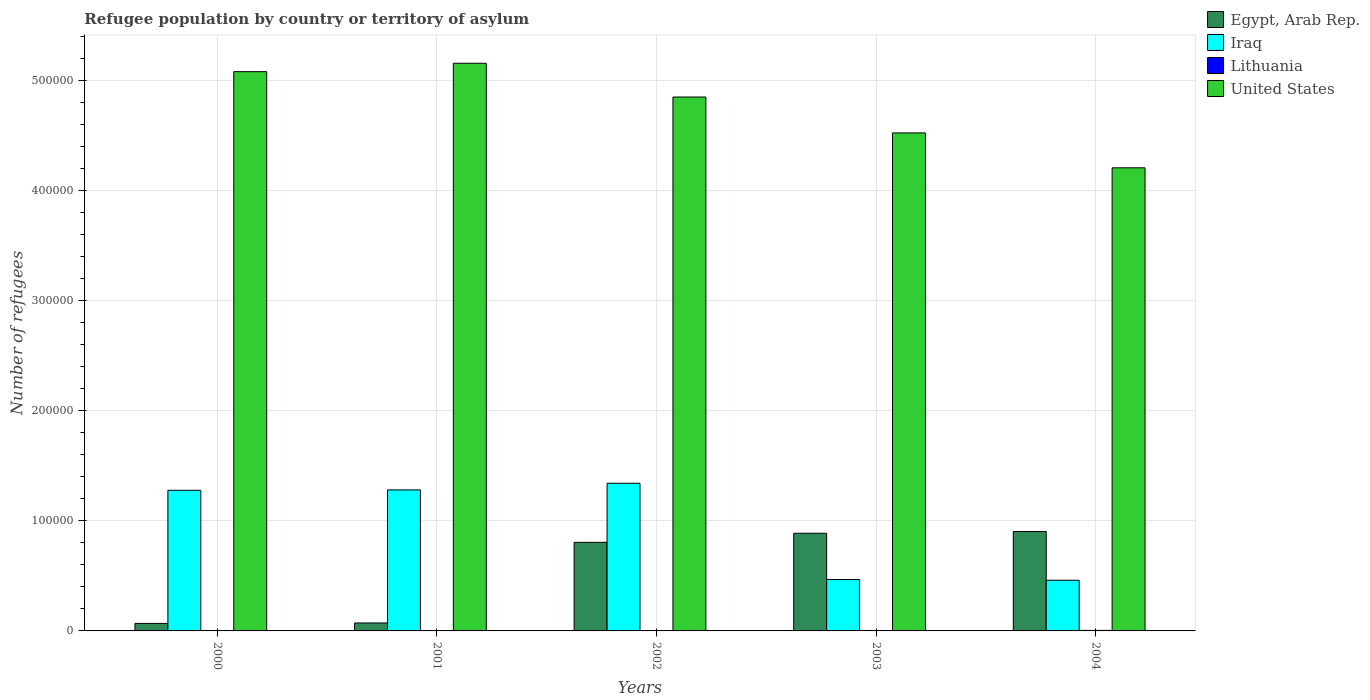How many bars are there on the 5th tick from the left?
Offer a terse response. 4. How many bars are there on the 5th tick from the right?
Make the answer very short. 4. What is the label of the 4th group of bars from the left?
Ensure brevity in your answer.  2003. In how many cases, is the number of bars for a given year not equal to the number of legend labels?
Your answer should be compact. 0. What is the number of refugees in United States in 2000?
Offer a terse response. 5.08e+05. Across all years, what is the maximum number of refugees in Iraq?
Offer a very short reply. 1.34e+05. Across all years, what is the minimum number of refugees in Iraq?
Your answer should be very brief. 4.61e+04. In which year was the number of refugees in United States minimum?
Your answer should be compact. 2004. What is the total number of refugees in United States in the graph?
Ensure brevity in your answer.  2.38e+06. What is the difference between the number of refugees in Iraq in 2002 and that in 2003?
Keep it short and to the point. 8.75e+04. What is the difference between the number of refugees in Egypt, Arab Rep. in 2001 and the number of refugees in United States in 2002?
Offer a terse response. -4.78e+05. What is the average number of refugees in Lithuania per year?
Offer a very short reply. 316.6. In the year 2004, what is the difference between the number of refugees in Lithuania and number of refugees in Iraq?
Your answer should be very brief. -4.56e+04. In how many years, is the number of refugees in Egypt, Arab Rep. greater than 360000?
Give a very brief answer. 0. What is the ratio of the number of refugees in Lithuania in 2003 to that in 2004?
Provide a succinct answer. 0.86. Is the number of refugees in Lithuania in 2000 less than that in 2001?
Offer a terse response. Yes. What is the difference between the highest and the second highest number of refugees in Iraq?
Your response must be concise. 6048. What is the difference between the highest and the lowest number of refugees in Lithuania?
Provide a short and direct response. 415. In how many years, is the number of refugees in Iraq greater than the average number of refugees in Iraq taken over all years?
Offer a very short reply. 3. What does the 1st bar from the left in 2003 represents?
Your answer should be compact. Egypt, Arab Rep. What does the 4th bar from the right in 2001 represents?
Keep it short and to the point. Egypt, Arab Rep. Is it the case that in every year, the sum of the number of refugees in Egypt, Arab Rep. and number of refugees in United States is greater than the number of refugees in Iraq?
Provide a succinct answer. Yes. How many bars are there?
Give a very brief answer. 20. How are the legend labels stacked?
Make the answer very short. Vertical. What is the title of the graph?
Keep it short and to the point. Refugee population by country or territory of asylum. Does "Kosovo" appear as one of the legend labels in the graph?
Keep it short and to the point. No. What is the label or title of the Y-axis?
Your response must be concise. Number of refugees. What is the Number of refugees of Egypt, Arab Rep. in 2000?
Offer a very short reply. 6840. What is the Number of refugees of Iraq in 2000?
Give a very brief answer. 1.28e+05. What is the Number of refugees of United States in 2000?
Ensure brevity in your answer.  5.08e+05. What is the Number of refugees in Egypt, Arab Rep. in 2001?
Provide a short and direct response. 7230. What is the Number of refugees in Iraq in 2001?
Your answer should be compact. 1.28e+05. What is the Number of refugees in Lithuania in 2001?
Provide a short and direct response. 287. What is the Number of refugees in United States in 2001?
Make the answer very short. 5.16e+05. What is the Number of refugees in Egypt, Arab Rep. in 2002?
Offer a very short reply. 8.05e+04. What is the Number of refugees of Iraq in 2002?
Make the answer very short. 1.34e+05. What is the Number of refugees in Lithuania in 2002?
Provide a short and direct response. 368. What is the Number of refugees in United States in 2002?
Your response must be concise. 4.85e+05. What is the Number of refugees of Egypt, Arab Rep. in 2003?
Your response must be concise. 8.87e+04. What is the Number of refugees in Iraq in 2003?
Provide a short and direct response. 4.67e+04. What is the Number of refugees of Lithuania in 2003?
Keep it short and to the point. 403. What is the Number of refugees in United States in 2003?
Provide a succinct answer. 4.53e+05. What is the Number of refugees of Egypt, Arab Rep. in 2004?
Your response must be concise. 9.03e+04. What is the Number of refugees of Iraq in 2004?
Your response must be concise. 4.61e+04. What is the Number of refugees of Lithuania in 2004?
Your response must be concise. 470. What is the Number of refugees of United States in 2004?
Make the answer very short. 4.21e+05. Across all years, what is the maximum Number of refugees of Egypt, Arab Rep.?
Offer a terse response. 9.03e+04. Across all years, what is the maximum Number of refugees of Iraq?
Your answer should be compact. 1.34e+05. Across all years, what is the maximum Number of refugees of Lithuania?
Ensure brevity in your answer.  470. Across all years, what is the maximum Number of refugees in United States?
Provide a short and direct response. 5.16e+05. Across all years, what is the minimum Number of refugees in Egypt, Arab Rep.?
Your response must be concise. 6840. Across all years, what is the minimum Number of refugees in Iraq?
Your answer should be very brief. 4.61e+04. Across all years, what is the minimum Number of refugees of Lithuania?
Provide a short and direct response. 55. Across all years, what is the minimum Number of refugees of United States?
Offer a terse response. 4.21e+05. What is the total Number of refugees in Egypt, Arab Rep. in the graph?
Give a very brief answer. 2.74e+05. What is the total Number of refugees of Iraq in the graph?
Offer a terse response. 4.83e+05. What is the total Number of refugees in Lithuania in the graph?
Your answer should be compact. 1583. What is the total Number of refugees of United States in the graph?
Keep it short and to the point. 2.38e+06. What is the difference between the Number of refugees of Egypt, Arab Rep. in 2000 and that in 2001?
Keep it short and to the point. -390. What is the difference between the Number of refugees of Iraq in 2000 and that in 2001?
Make the answer very short. -355. What is the difference between the Number of refugees in Lithuania in 2000 and that in 2001?
Your answer should be very brief. -232. What is the difference between the Number of refugees in United States in 2000 and that in 2001?
Your answer should be very brief. -7631. What is the difference between the Number of refugees of Egypt, Arab Rep. in 2000 and that in 2002?
Your answer should be compact. -7.37e+04. What is the difference between the Number of refugees in Iraq in 2000 and that in 2002?
Make the answer very short. -6403. What is the difference between the Number of refugees of Lithuania in 2000 and that in 2002?
Ensure brevity in your answer.  -313. What is the difference between the Number of refugees of United States in 2000 and that in 2002?
Make the answer very short. 2.31e+04. What is the difference between the Number of refugees of Egypt, Arab Rep. in 2000 and that in 2003?
Give a very brief answer. -8.19e+04. What is the difference between the Number of refugees of Iraq in 2000 and that in 2003?
Make the answer very short. 8.11e+04. What is the difference between the Number of refugees of Lithuania in 2000 and that in 2003?
Provide a succinct answer. -348. What is the difference between the Number of refugees in United States in 2000 and that in 2003?
Keep it short and to the point. 5.57e+04. What is the difference between the Number of refugees of Egypt, Arab Rep. in 2000 and that in 2004?
Provide a succinct answer. -8.35e+04. What is the difference between the Number of refugees of Iraq in 2000 and that in 2004?
Provide a succinct answer. 8.17e+04. What is the difference between the Number of refugees in Lithuania in 2000 and that in 2004?
Provide a short and direct response. -415. What is the difference between the Number of refugees in United States in 2000 and that in 2004?
Give a very brief answer. 8.74e+04. What is the difference between the Number of refugees in Egypt, Arab Rep. in 2001 and that in 2002?
Your response must be concise. -7.33e+04. What is the difference between the Number of refugees of Iraq in 2001 and that in 2002?
Your response must be concise. -6048. What is the difference between the Number of refugees in Lithuania in 2001 and that in 2002?
Give a very brief answer. -81. What is the difference between the Number of refugees of United States in 2001 and that in 2002?
Your response must be concise. 3.07e+04. What is the difference between the Number of refugees in Egypt, Arab Rep. in 2001 and that in 2003?
Provide a short and direct response. -8.15e+04. What is the difference between the Number of refugees in Iraq in 2001 and that in 2003?
Keep it short and to the point. 8.14e+04. What is the difference between the Number of refugees in Lithuania in 2001 and that in 2003?
Provide a succinct answer. -116. What is the difference between the Number of refugees of United States in 2001 and that in 2003?
Provide a succinct answer. 6.33e+04. What is the difference between the Number of refugees in Egypt, Arab Rep. in 2001 and that in 2004?
Give a very brief answer. -8.31e+04. What is the difference between the Number of refugees in Iraq in 2001 and that in 2004?
Make the answer very short. 8.21e+04. What is the difference between the Number of refugees in Lithuania in 2001 and that in 2004?
Offer a terse response. -183. What is the difference between the Number of refugees of United States in 2001 and that in 2004?
Your answer should be compact. 9.50e+04. What is the difference between the Number of refugees in Egypt, Arab Rep. in 2002 and that in 2003?
Your answer should be compact. -8255. What is the difference between the Number of refugees of Iraq in 2002 and that in 2003?
Provide a succinct answer. 8.75e+04. What is the difference between the Number of refugees in Lithuania in 2002 and that in 2003?
Offer a terse response. -35. What is the difference between the Number of refugees in United States in 2002 and that in 2003?
Give a very brief answer. 3.26e+04. What is the difference between the Number of refugees in Egypt, Arab Rep. in 2002 and that in 2004?
Your response must be concise. -9849. What is the difference between the Number of refugees of Iraq in 2002 and that in 2004?
Your response must be concise. 8.81e+04. What is the difference between the Number of refugees of Lithuania in 2002 and that in 2004?
Give a very brief answer. -102. What is the difference between the Number of refugees in United States in 2002 and that in 2004?
Your response must be concise. 6.43e+04. What is the difference between the Number of refugees in Egypt, Arab Rep. in 2003 and that in 2004?
Offer a terse response. -1594. What is the difference between the Number of refugees in Iraq in 2003 and that in 2004?
Give a very brief answer. 668. What is the difference between the Number of refugees in Lithuania in 2003 and that in 2004?
Offer a terse response. -67. What is the difference between the Number of refugees in United States in 2003 and that in 2004?
Make the answer very short. 3.17e+04. What is the difference between the Number of refugees of Egypt, Arab Rep. in 2000 and the Number of refugees of Iraq in 2001?
Provide a succinct answer. -1.21e+05. What is the difference between the Number of refugees in Egypt, Arab Rep. in 2000 and the Number of refugees in Lithuania in 2001?
Ensure brevity in your answer.  6553. What is the difference between the Number of refugees of Egypt, Arab Rep. in 2000 and the Number of refugees of United States in 2001?
Offer a very short reply. -5.09e+05. What is the difference between the Number of refugees of Iraq in 2000 and the Number of refugees of Lithuania in 2001?
Provide a short and direct response. 1.28e+05. What is the difference between the Number of refugees of Iraq in 2000 and the Number of refugees of United States in 2001?
Provide a short and direct response. -3.88e+05. What is the difference between the Number of refugees of Lithuania in 2000 and the Number of refugees of United States in 2001?
Give a very brief answer. -5.16e+05. What is the difference between the Number of refugees in Egypt, Arab Rep. in 2000 and the Number of refugees in Iraq in 2002?
Offer a very short reply. -1.27e+05. What is the difference between the Number of refugees in Egypt, Arab Rep. in 2000 and the Number of refugees in Lithuania in 2002?
Your answer should be compact. 6472. What is the difference between the Number of refugees of Egypt, Arab Rep. in 2000 and the Number of refugees of United States in 2002?
Offer a very short reply. -4.78e+05. What is the difference between the Number of refugees of Iraq in 2000 and the Number of refugees of Lithuania in 2002?
Your answer should be very brief. 1.27e+05. What is the difference between the Number of refugees in Iraq in 2000 and the Number of refugees in United States in 2002?
Provide a succinct answer. -3.57e+05. What is the difference between the Number of refugees of Lithuania in 2000 and the Number of refugees of United States in 2002?
Give a very brief answer. -4.85e+05. What is the difference between the Number of refugees in Egypt, Arab Rep. in 2000 and the Number of refugees in Iraq in 2003?
Keep it short and to the point. -3.99e+04. What is the difference between the Number of refugees of Egypt, Arab Rep. in 2000 and the Number of refugees of Lithuania in 2003?
Make the answer very short. 6437. What is the difference between the Number of refugees of Egypt, Arab Rep. in 2000 and the Number of refugees of United States in 2003?
Ensure brevity in your answer.  -4.46e+05. What is the difference between the Number of refugees in Iraq in 2000 and the Number of refugees in Lithuania in 2003?
Provide a short and direct response. 1.27e+05. What is the difference between the Number of refugees of Iraq in 2000 and the Number of refugees of United States in 2003?
Make the answer very short. -3.25e+05. What is the difference between the Number of refugees of Lithuania in 2000 and the Number of refugees of United States in 2003?
Provide a short and direct response. -4.52e+05. What is the difference between the Number of refugees of Egypt, Arab Rep. in 2000 and the Number of refugees of Iraq in 2004?
Offer a terse response. -3.92e+04. What is the difference between the Number of refugees of Egypt, Arab Rep. in 2000 and the Number of refugees of Lithuania in 2004?
Your response must be concise. 6370. What is the difference between the Number of refugees in Egypt, Arab Rep. in 2000 and the Number of refugees in United States in 2004?
Ensure brevity in your answer.  -4.14e+05. What is the difference between the Number of refugees in Iraq in 2000 and the Number of refugees in Lithuania in 2004?
Your response must be concise. 1.27e+05. What is the difference between the Number of refugees in Iraq in 2000 and the Number of refugees in United States in 2004?
Make the answer very short. -2.93e+05. What is the difference between the Number of refugees in Lithuania in 2000 and the Number of refugees in United States in 2004?
Keep it short and to the point. -4.21e+05. What is the difference between the Number of refugees of Egypt, Arab Rep. in 2001 and the Number of refugees of Iraq in 2002?
Provide a succinct answer. -1.27e+05. What is the difference between the Number of refugees in Egypt, Arab Rep. in 2001 and the Number of refugees in Lithuania in 2002?
Give a very brief answer. 6862. What is the difference between the Number of refugees in Egypt, Arab Rep. in 2001 and the Number of refugees in United States in 2002?
Give a very brief answer. -4.78e+05. What is the difference between the Number of refugees of Iraq in 2001 and the Number of refugees of Lithuania in 2002?
Give a very brief answer. 1.28e+05. What is the difference between the Number of refugees of Iraq in 2001 and the Number of refugees of United States in 2002?
Provide a succinct answer. -3.57e+05. What is the difference between the Number of refugees of Lithuania in 2001 and the Number of refugees of United States in 2002?
Your response must be concise. -4.85e+05. What is the difference between the Number of refugees of Egypt, Arab Rep. in 2001 and the Number of refugees of Iraq in 2003?
Offer a terse response. -3.95e+04. What is the difference between the Number of refugees in Egypt, Arab Rep. in 2001 and the Number of refugees in Lithuania in 2003?
Make the answer very short. 6827. What is the difference between the Number of refugees in Egypt, Arab Rep. in 2001 and the Number of refugees in United States in 2003?
Provide a short and direct response. -4.45e+05. What is the difference between the Number of refugees in Iraq in 2001 and the Number of refugees in Lithuania in 2003?
Give a very brief answer. 1.28e+05. What is the difference between the Number of refugees in Iraq in 2001 and the Number of refugees in United States in 2003?
Offer a very short reply. -3.24e+05. What is the difference between the Number of refugees in Lithuania in 2001 and the Number of refugees in United States in 2003?
Provide a short and direct response. -4.52e+05. What is the difference between the Number of refugees of Egypt, Arab Rep. in 2001 and the Number of refugees of Iraq in 2004?
Ensure brevity in your answer.  -3.88e+04. What is the difference between the Number of refugees of Egypt, Arab Rep. in 2001 and the Number of refugees of Lithuania in 2004?
Your answer should be compact. 6760. What is the difference between the Number of refugees in Egypt, Arab Rep. in 2001 and the Number of refugees in United States in 2004?
Ensure brevity in your answer.  -4.14e+05. What is the difference between the Number of refugees in Iraq in 2001 and the Number of refugees in Lithuania in 2004?
Provide a short and direct response. 1.28e+05. What is the difference between the Number of refugees of Iraq in 2001 and the Number of refugees of United States in 2004?
Keep it short and to the point. -2.93e+05. What is the difference between the Number of refugees in Lithuania in 2001 and the Number of refugees in United States in 2004?
Provide a succinct answer. -4.21e+05. What is the difference between the Number of refugees in Egypt, Arab Rep. in 2002 and the Number of refugees in Iraq in 2003?
Offer a very short reply. 3.38e+04. What is the difference between the Number of refugees of Egypt, Arab Rep. in 2002 and the Number of refugees of Lithuania in 2003?
Offer a very short reply. 8.01e+04. What is the difference between the Number of refugees in Egypt, Arab Rep. in 2002 and the Number of refugees in United States in 2003?
Your answer should be compact. -3.72e+05. What is the difference between the Number of refugees in Iraq in 2002 and the Number of refugees in Lithuania in 2003?
Make the answer very short. 1.34e+05. What is the difference between the Number of refugees of Iraq in 2002 and the Number of refugees of United States in 2003?
Offer a very short reply. -3.18e+05. What is the difference between the Number of refugees in Lithuania in 2002 and the Number of refugees in United States in 2003?
Your answer should be compact. -4.52e+05. What is the difference between the Number of refugees in Egypt, Arab Rep. in 2002 and the Number of refugees in Iraq in 2004?
Your answer should be very brief. 3.44e+04. What is the difference between the Number of refugees of Egypt, Arab Rep. in 2002 and the Number of refugees of Lithuania in 2004?
Ensure brevity in your answer.  8.00e+04. What is the difference between the Number of refugees of Egypt, Arab Rep. in 2002 and the Number of refugees of United States in 2004?
Make the answer very short. -3.40e+05. What is the difference between the Number of refugees in Iraq in 2002 and the Number of refugees in Lithuania in 2004?
Your answer should be very brief. 1.34e+05. What is the difference between the Number of refugees of Iraq in 2002 and the Number of refugees of United States in 2004?
Provide a succinct answer. -2.87e+05. What is the difference between the Number of refugees in Lithuania in 2002 and the Number of refugees in United States in 2004?
Offer a terse response. -4.20e+05. What is the difference between the Number of refugees of Egypt, Arab Rep. in 2003 and the Number of refugees of Iraq in 2004?
Keep it short and to the point. 4.27e+04. What is the difference between the Number of refugees of Egypt, Arab Rep. in 2003 and the Number of refugees of Lithuania in 2004?
Provide a short and direct response. 8.83e+04. What is the difference between the Number of refugees in Egypt, Arab Rep. in 2003 and the Number of refugees in United States in 2004?
Your response must be concise. -3.32e+05. What is the difference between the Number of refugees of Iraq in 2003 and the Number of refugees of Lithuania in 2004?
Make the answer very short. 4.63e+04. What is the difference between the Number of refugees in Iraq in 2003 and the Number of refugees in United States in 2004?
Your response must be concise. -3.74e+05. What is the difference between the Number of refugees in Lithuania in 2003 and the Number of refugees in United States in 2004?
Keep it short and to the point. -4.20e+05. What is the average Number of refugees in Egypt, Arab Rep. per year?
Give a very brief answer. 5.47e+04. What is the average Number of refugees of Iraq per year?
Keep it short and to the point. 9.66e+04. What is the average Number of refugees in Lithuania per year?
Offer a terse response. 316.6. What is the average Number of refugees in United States per year?
Ensure brevity in your answer.  4.77e+05. In the year 2000, what is the difference between the Number of refugees in Egypt, Arab Rep. and Number of refugees in Iraq?
Provide a succinct answer. -1.21e+05. In the year 2000, what is the difference between the Number of refugees of Egypt, Arab Rep. and Number of refugees of Lithuania?
Keep it short and to the point. 6785. In the year 2000, what is the difference between the Number of refugees in Egypt, Arab Rep. and Number of refugees in United States?
Provide a short and direct response. -5.01e+05. In the year 2000, what is the difference between the Number of refugees in Iraq and Number of refugees in Lithuania?
Offer a terse response. 1.28e+05. In the year 2000, what is the difference between the Number of refugees of Iraq and Number of refugees of United States?
Offer a very short reply. -3.80e+05. In the year 2000, what is the difference between the Number of refugees in Lithuania and Number of refugees in United States?
Provide a short and direct response. -5.08e+05. In the year 2001, what is the difference between the Number of refugees in Egypt, Arab Rep. and Number of refugees in Iraq?
Make the answer very short. -1.21e+05. In the year 2001, what is the difference between the Number of refugees of Egypt, Arab Rep. and Number of refugees of Lithuania?
Keep it short and to the point. 6943. In the year 2001, what is the difference between the Number of refugees in Egypt, Arab Rep. and Number of refugees in United States?
Your response must be concise. -5.09e+05. In the year 2001, what is the difference between the Number of refugees of Iraq and Number of refugees of Lithuania?
Offer a terse response. 1.28e+05. In the year 2001, what is the difference between the Number of refugees of Iraq and Number of refugees of United States?
Provide a short and direct response. -3.88e+05. In the year 2001, what is the difference between the Number of refugees of Lithuania and Number of refugees of United States?
Keep it short and to the point. -5.16e+05. In the year 2002, what is the difference between the Number of refugees in Egypt, Arab Rep. and Number of refugees in Iraq?
Give a very brief answer. -5.37e+04. In the year 2002, what is the difference between the Number of refugees in Egypt, Arab Rep. and Number of refugees in Lithuania?
Offer a terse response. 8.01e+04. In the year 2002, what is the difference between the Number of refugees in Egypt, Arab Rep. and Number of refugees in United States?
Your answer should be compact. -4.05e+05. In the year 2002, what is the difference between the Number of refugees of Iraq and Number of refugees of Lithuania?
Your answer should be very brief. 1.34e+05. In the year 2002, what is the difference between the Number of refugees of Iraq and Number of refugees of United States?
Provide a succinct answer. -3.51e+05. In the year 2002, what is the difference between the Number of refugees of Lithuania and Number of refugees of United States?
Ensure brevity in your answer.  -4.85e+05. In the year 2003, what is the difference between the Number of refugees of Egypt, Arab Rep. and Number of refugees of Iraq?
Offer a terse response. 4.20e+04. In the year 2003, what is the difference between the Number of refugees of Egypt, Arab Rep. and Number of refugees of Lithuania?
Your response must be concise. 8.83e+04. In the year 2003, what is the difference between the Number of refugees of Egypt, Arab Rep. and Number of refugees of United States?
Give a very brief answer. -3.64e+05. In the year 2003, what is the difference between the Number of refugees of Iraq and Number of refugees of Lithuania?
Provide a succinct answer. 4.63e+04. In the year 2003, what is the difference between the Number of refugees in Iraq and Number of refugees in United States?
Offer a terse response. -4.06e+05. In the year 2003, what is the difference between the Number of refugees of Lithuania and Number of refugees of United States?
Ensure brevity in your answer.  -4.52e+05. In the year 2004, what is the difference between the Number of refugees of Egypt, Arab Rep. and Number of refugees of Iraq?
Your answer should be very brief. 4.43e+04. In the year 2004, what is the difference between the Number of refugees in Egypt, Arab Rep. and Number of refugees in Lithuania?
Your answer should be compact. 8.99e+04. In the year 2004, what is the difference between the Number of refugees in Egypt, Arab Rep. and Number of refugees in United States?
Make the answer very short. -3.31e+05. In the year 2004, what is the difference between the Number of refugees in Iraq and Number of refugees in Lithuania?
Give a very brief answer. 4.56e+04. In the year 2004, what is the difference between the Number of refugees of Iraq and Number of refugees of United States?
Your answer should be compact. -3.75e+05. In the year 2004, what is the difference between the Number of refugees of Lithuania and Number of refugees of United States?
Ensure brevity in your answer.  -4.20e+05. What is the ratio of the Number of refugees in Egypt, Arab Rep. in 2000 to that in 2001?
Give a very brief answer. 0.95. What is the ratio of the Number of refugees of Lithuania in 2000 to that in 2001?
Make the answer very short. 0.19. What is the ratio of the Number of refugees in United States in 2000 to that in 2001?
Your answer should be very brief. 0.99. What is the ratio of the Number of refugees in Egypt, Arab Rep. in 2000 to that in 2002?
Make the answer very short. 0.09. What is the ratio of the Number of refugees in Iraq in 2000 to that in 2002?
Provide a short and direct response. 0.95. What is the ratio of the Number of refugees in Lithuania in 2000 to that in 2002?
Make the answer very short. 0.15. What is the ratio of the Number of refugees in United States in 2000 to that in 2002?
Ensure brevity in your answer.  1.05. What is the ratio of the Number of refugees of Egypt, Arab Rep. in 2000 to that in 2003?
Provide a succinct answer. 0.08. What is the ratio of the Number of refugees in Iraq in 2000 to that in 2003?
Offer a terse response. 2.74. What is the ratio of the Number of refugees in Lithuania in 2000 to that in 2003?
Provide a succinct answer. 0.14. What is the ratio of the Number of refugees in United States in 2000 to that in 2003?
Give a very brief answer. 1.12. What is the ratio of the Number of refugees of Egypt, Arab Rep. in 2000 to that in 2004?
Give a very brief answer. 0.08. What is the ratio of the Number of refugees in Iraq in 2000 to that in 2004?
Your answer should be compact. 2.77. What is the ratio of the Number of refugees of Lithuania in 2000 to that in 2004?
Offer a terse response. 0.12. What is the ratio of the Number of refugees of United States in 2000 to that in 2004?
Your response must be concise. 1.21. What is the ratio of the Number of refugees in Egypt, Arab Rep. in 2001 to that in 2002?
Give a very brief answer. 0.09. What is the ratio of the Number of refugees of Iraq in 2001 to that in 2002?
Offer a very short reply. 0.95. What is the ratio of the Number of refugees in Lithuania in 2001 to that in 2002?
Provide a succinct answer. 0.78. What is the ratio of the Number of refugees in United States in 2001 to that in 2002?
Your answer should be very brief. 1.06. What is the ratio of the Number of refugees of Egypt, Arab Rep. in 2001 to that in 2003?
Provide a short and direct response. 0.08. What is the ratio of the Number of refugees of Iraq in 2001 to that in 2003?
Offer a terse response. 2.74. What is the ratio of the Number of refugees of Lithuania in 2001 to that in 2003?
Ensure brevity in your answer.  0.71. What is the ratio of the Number of refugees of United States in 2001 to that in 2003?
Give a very brief answer. 1.14. What is the ratio of the Number of refugees of Iraq in 2001 to that in 2004?
Your answer should be very brief. 2.78. What is the ratio of the Number of refugees of Lithuania in 2001 to that in 2004?
Provide a succinct answer. 0.61. What is the ratio of the Number of refugees of United States in 2001 to that in 2004?
Your answer should be compact. 1.23. What is the ratio of the Number of refugees of Egypt, Arab Rep. in 2002 to that in 2003?
Provide a short and direct response. 0.91. What is the ratio of the Number of refugees in Iraq in 2002 to that in 2003?
Offer a very short reply. 2.87. What is the ratio of the Number of refugees of Lithuania in 2002 to that in 2003?
Offer a terse response. 0.91. What is the ratio of the Number of refugees of United States in 2002 to that in 2003?
Your answer should be very brief. 1.07. What is the ratio of the Number of refugees of Egypt, Arab Rep. in 2002 to that in 2004?
Offer a very short reply. 0.89. What is the ratio of the Number of refugees of Iraq in 2002 to that in 2004?
Offer a terse response. 2.91. What is the ratio of the Number of refugees in Lithuania in 2002 to that in 2004?
Offer a terse response. 0.78. What is the ratio of the Number of refugees in United States in 2002 to that in 2004?
Give a very brief answer. 1.15. What is the ratio of the Number of refugees in Egypt, Arab Rep. in 2003 to that in 2004?
Provide a short and direct response. 0.98. What is the ratio of the Number of refugees in Iraq in 2003 to that in 2004?
Your answer should be very brief. 1.01. What is the ratio of the Number of refugees of Lithuania in 2003 to that in 2004?
Your response must be concise. 0.86. What is the ratio of the Number of refugees in United States in 2003 to that in 2004?
Provide a short and direct response. 1.08. What is the difference between the highest and the second highest Number of refugees of Egypt, Arab Rep.?
Provide a succinct answer. 1594. What is the difference between the highest and the second highest Number of refugees of Iraq?
Your response must be concise. 6048. What is the difference between the highest and the second highest Number of refugees of Lithuania?
Your response must be concise. 67. What is the difference between the highest and the second highest Number of refugees in United States?
Keep it short and to the point. 7631. What is the difference between the highest and the lowest Number of refugees of Egypt, Arab Rep.?
Your answer should be compact. 8.35e+04. What is the difference between the highest and the lowest Number of refugees in Iraq?
Provide a succinct answer. 8.81e+04. What is the difference between the highest and the lowest Number of refugees of Lithuania?
Provide a short and direct response. 415. What is the difference between the highest and the lowest Number of refugees in United States?
Ensure brevity in your answer.  9.50e+04. 